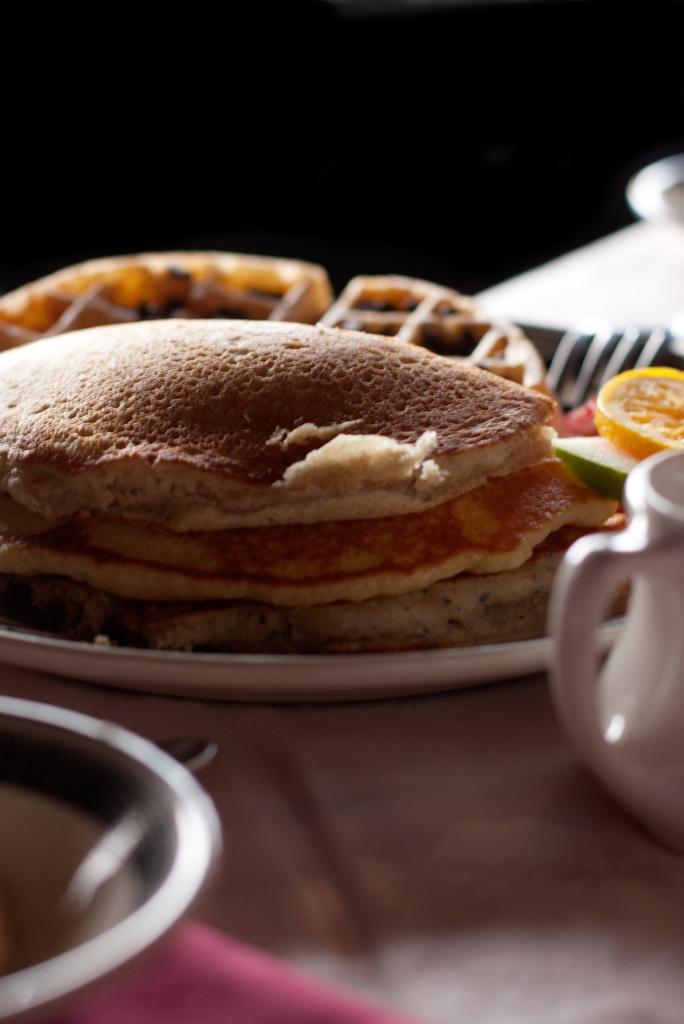Can you describe this image briefly? Here I can see a table which is covered with a cloth. On the table a plate, bowl, fork. jar and some other objects are placed. On the plate, I can see some food item. The background is dark. 